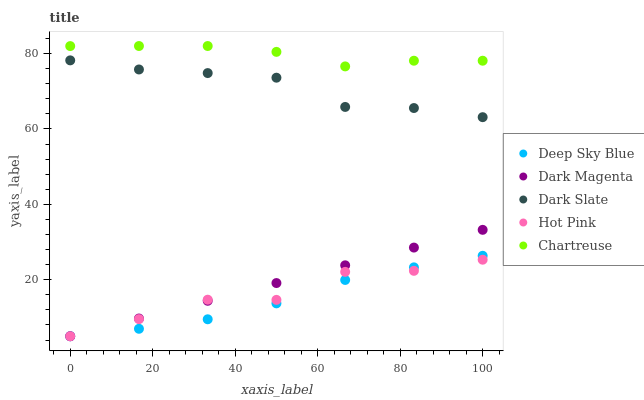Does Deep Sky Blue have the minimum area under the curve?
Answer yes or no. Yes. Does Chartreuse have the maximum area under the curve?
Answer yes or no. Yes. Does Hot Pink have the minimum area under the curve?
Answer yes or no. No. Does Hot Pink have the maximum area under the curve?
Answer yes or no. No. Is Dark Magenta the smoothest?
Answer yes or no. Yes. Is Hot Pink the roughest?
Answer yes or no. Yes. Is Chartreuse the smoothest?
Answer yes or no. No. Is Chartreuse the roughest?
Answer yes or no. No. Does Hot Pink have the lowest value?
Answer yes or no. Yes. Does Chartreuse have the lowest value?
Answer yes or no. No. Does Chartreuse have the highest value?
Answer yes or no. Yes. Does Hot Pink have the highest value?
Answer yes or no. No. Is Dark Magenta less than Dark Slate?
Answer yes or no. Yes. Is Chartreuse greater than Deep Sky Blue?
Answer yes or no. Yes. Does Hot Pink intersect Dark Magenta?
Answer yes or no. Yes. Is Hot Pink less than Dark Magenta?
Answer yes or no. No. Is Hot Pink greater than Dark Magenta?
Answer yes or no. No. Does Dark Magenta intersect Dark Slate?
Answer yes or no. No. 